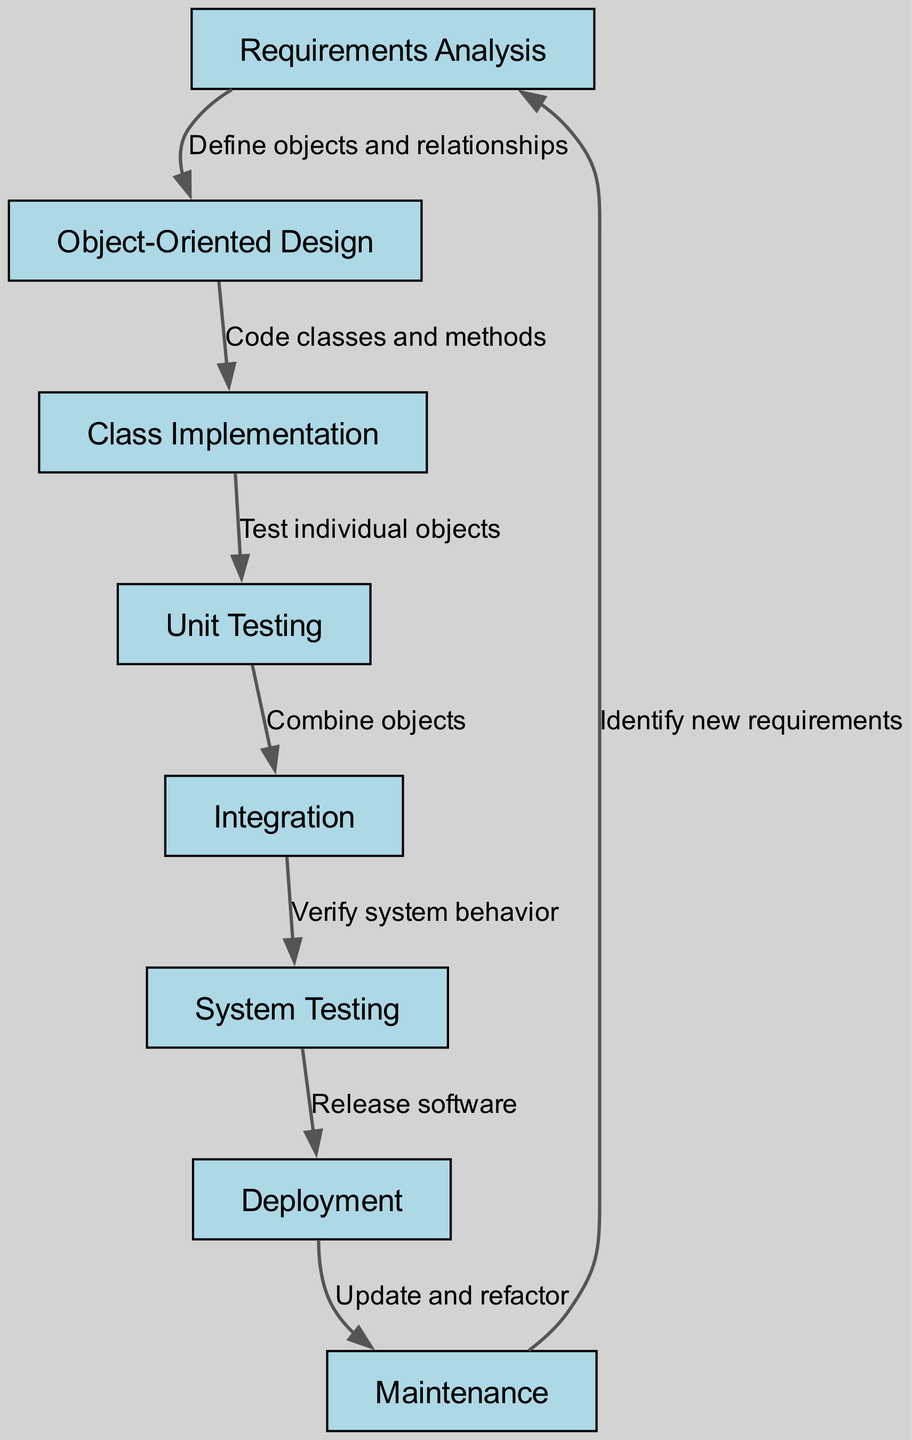What is the first step in the software development lifecycle? According to the diagram, the first node is "Requirements Analysis," indicating that this is the starting point for the software development lifecycle using object-oriented principles.
Answer: Requirements Analysis How many nodes are present in the diagram? By counting each distinct step from the provided node data, there are 8 nodes listed, ranging from "Requirements Analysis" to "Maintenance."
Answer: 8 What follows after "Object-Oriented Design"? The diagram shows an edge leading from "Object-Oriented Design" to "Class Implementation," indicating that this is the next step in the process.
Answer: Class Implementation Which step involves testing individual objects? The edge from "Class Implementation" leads to "Unit Testing," which indicates that unit testing is specifically about testing individual objects created in the implementation step.
Answer: Unit Testing What is the relationship between "System Testing" and "Deployment"? The diagram establishes a direct flow from "System Testing" to "Deployment," signifying that system testing must be completed before the software can be released into deployment.
Answer: Release software What do you do after "Deployment"? The flow indicates that after deployment, the next step is "Maintenance," highlighting that post-deployment activities involve updating and refactoring.
Answer: Maintenance How many edges are represented in the diagram? By examining the connections between nodes, there are 7 edges that indicate the transitions between the steps in the software development lifecycle.
Answer: 7 What action is identified in the relationship between "Maintenance" and "Requirements Analysis"? The relationship shows that "Maintenance" leads back to "Requirements Analysis," indicating that during maintenance, new requirements are identified for further software development.
Answer: Identify new requirements What step comes after "Unit Testing"? The diagram illustrates that the next phase after "Unit Testing" is "Integration," which involves combining various objects once they have passed unit tests.
Answer: Integration 